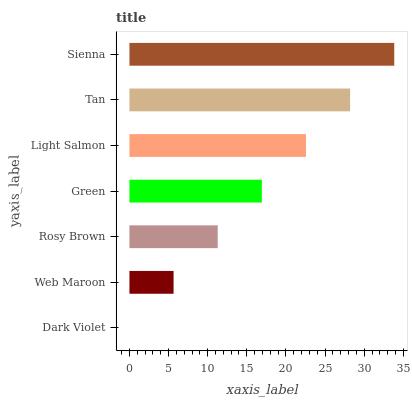Is Dark Violet the minimum?
Answer yes or no. Yes. Is Sienna the maximum?
Answer yes or no. Yes. Is Web Maroon the minimum?
Answer yes or no. No. Is Web Maroon the maximum?
Answer yes or no. No. Is Web Maroon greater than Dark Violet?
Answer yes or no. Yes. Is Dark Violet less than Web Maroon?
Answer yes or no. Yes. Is Dark Violet greater than Web Maroon?
Answer yes or no. No. Is Web Maroon less than Dark Violet?
Answer yes or no. No. Is Green the high median?
Answer yes or no. Yes. Is Green the low median?
Answer yes or no. Yes. Is Sienna the high median?
Answer yes or no. No. Is Dark Violet the low median?
Answer yes or no. No. 